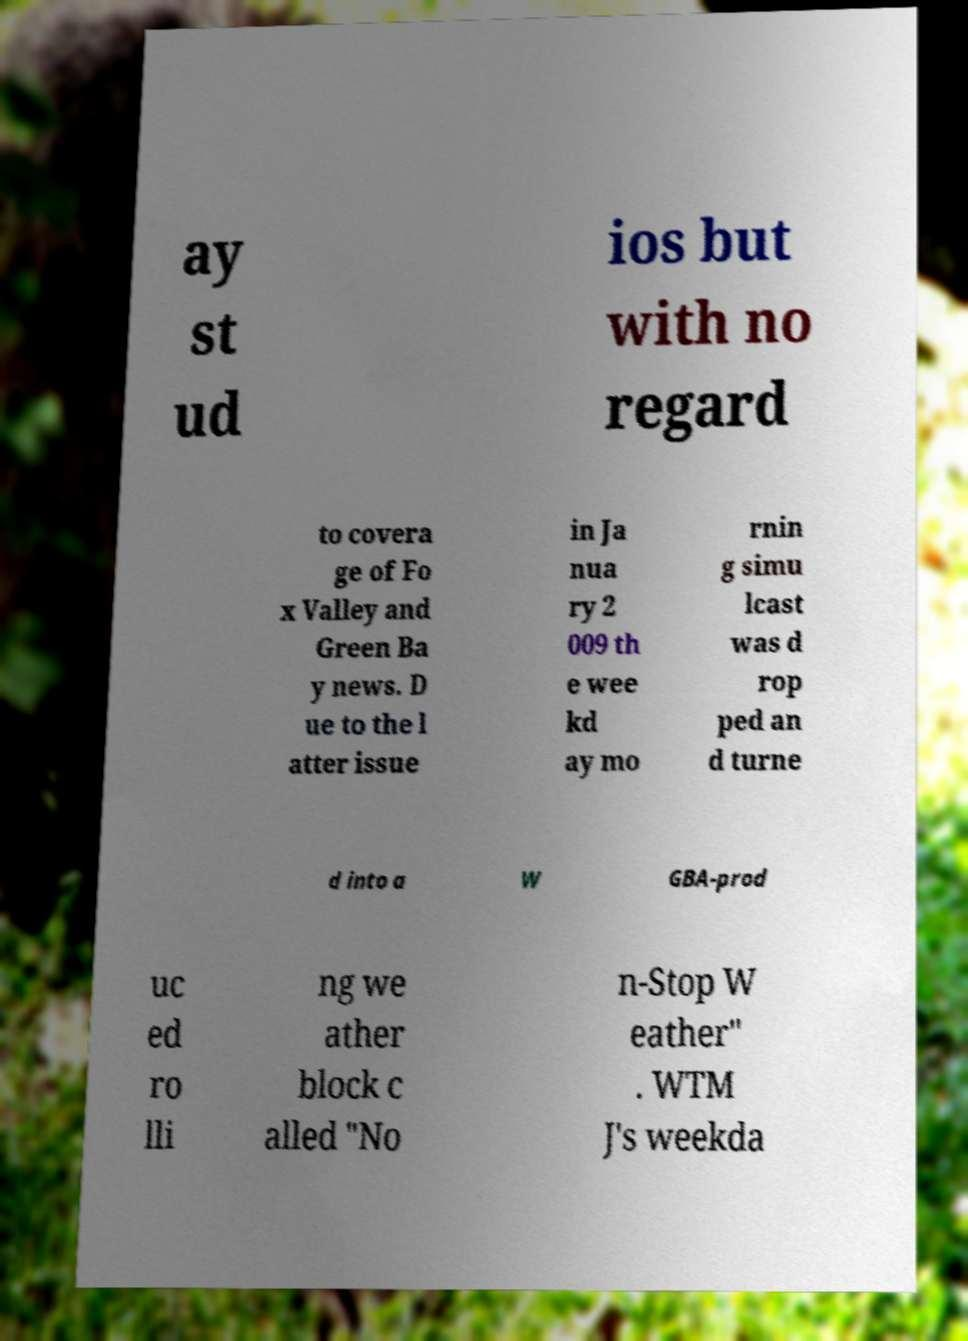Please identify and transcribe the text found in this image. ay st ud ios but with no regard to covera ge of Fo x Valley and Green Ba y news. D ue to the l atter issue in Ja nua ry 2 009 th e wee kd ay mo rnin g simu lcast was d rop ped an d turne d into a W GBA-prod uc ed ro lli ng we ather block c alled "No n-Stop W eather" . WTM J's weekda 